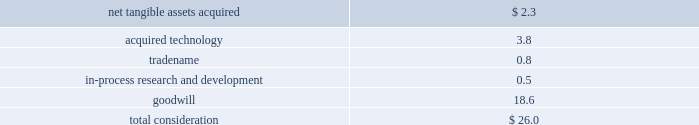Notes to consolidated financial statements ( continued ) note 4 2014acquisitions ( continued ) acquisition of emagic gmbh during the fourth quarter of 2002 , the company acquired emagic gmbh ( emagic ) , a provider of professional software solutions for computer based music production , for approximately $ 30 million in cash ; $ 26 million of which was paid immediately upon closing of the deal and $ 4 million of which was held-back for future payment contingent on continued employment by certain employees that would be allocated to future compensation expense in the appropriate periods over the following 3 years .
During fiscal 2003 , contingent consideration totaling $ 1.3 million was paid .
The acquisition has been accounted for as a purchase .
The portion of the purchase price allocated to purchased in-process research and development ( ipr&d ) was expensed immediately , and the portion of the purchase price allocated to acquired technology and to tradename will be amortized over their estimated useful lives of 3 years .
Goodwill associated with the acquisition of emagic is not subject to amortization pursuant to the provisions of sfas no .
142 .
Total consideration was allocated as follows ( in millions ) : .
The amount of the purchase price allocated to ipr&d was expensed upon acquisition , because the technological feasibility of products under development had not been established and no alternative future uses existed .
The ipr&d relates primarily to emagic 2019s logic series technology and extensions .
At the date of the acquisition , the products under development were between 43%-83% ( 43%-83 % ) complete , and it was expected that the remaining work would be completed during the company 2019s fiscal 2003 at a cost of approximately $ 415000 .
The remaining efforts , which were completed in 2003 , included finalizing user interface design and development , and testing .
The fair value of the ipr&d was determined using an income approach , which reflects the projected free cash flows that will be generated by the ipr&d projects and that are attributable to the acquired technology , and discounting the projected net cash flows back to their present value using a discount rate of 25% ( 25 % ) .
Acquisition of certain assets of zayante , inc. , prismo graphics , and silicon grail during fiscal 2002 the company acquired certain technology and patent rights of zayante , inc. , prismo graphics , and silicon grail corporation for a total of $ 20 million in cash .
These transactions have been accounted for as asset acquisitions .
The purchase price for these asset acquisitions , except for $ 1 million identified as contingent consideration which would be allocated to compensation expense over the following 3 years , has been allocated to acquired technology and would be amortized on a straight-line basis over 3 years , except for certain assets acquired from zayante associated with patent royalty streams that would be amortized over 10 years .
Acquisition of nothing real , llc during the second quarter of 2002 , the company acquired certain assets of nothing real , llc ( nothing real ) , a privately-held company that develops and markets high performance tools designed for the digital image creation market .
Of the $ 15 million purchase price , the company has allocated $ 7 million to acquired technology , which will be amortized over its estimated life of 5 years .
The remaining $ 8 million , which has been identified as contingent consideration , rather than recorded as an additional component of .
What percentage of the purchase price was spent on acquired technology? 
Computations: (3.8 / 26.0)
Answer: 0.14615. 